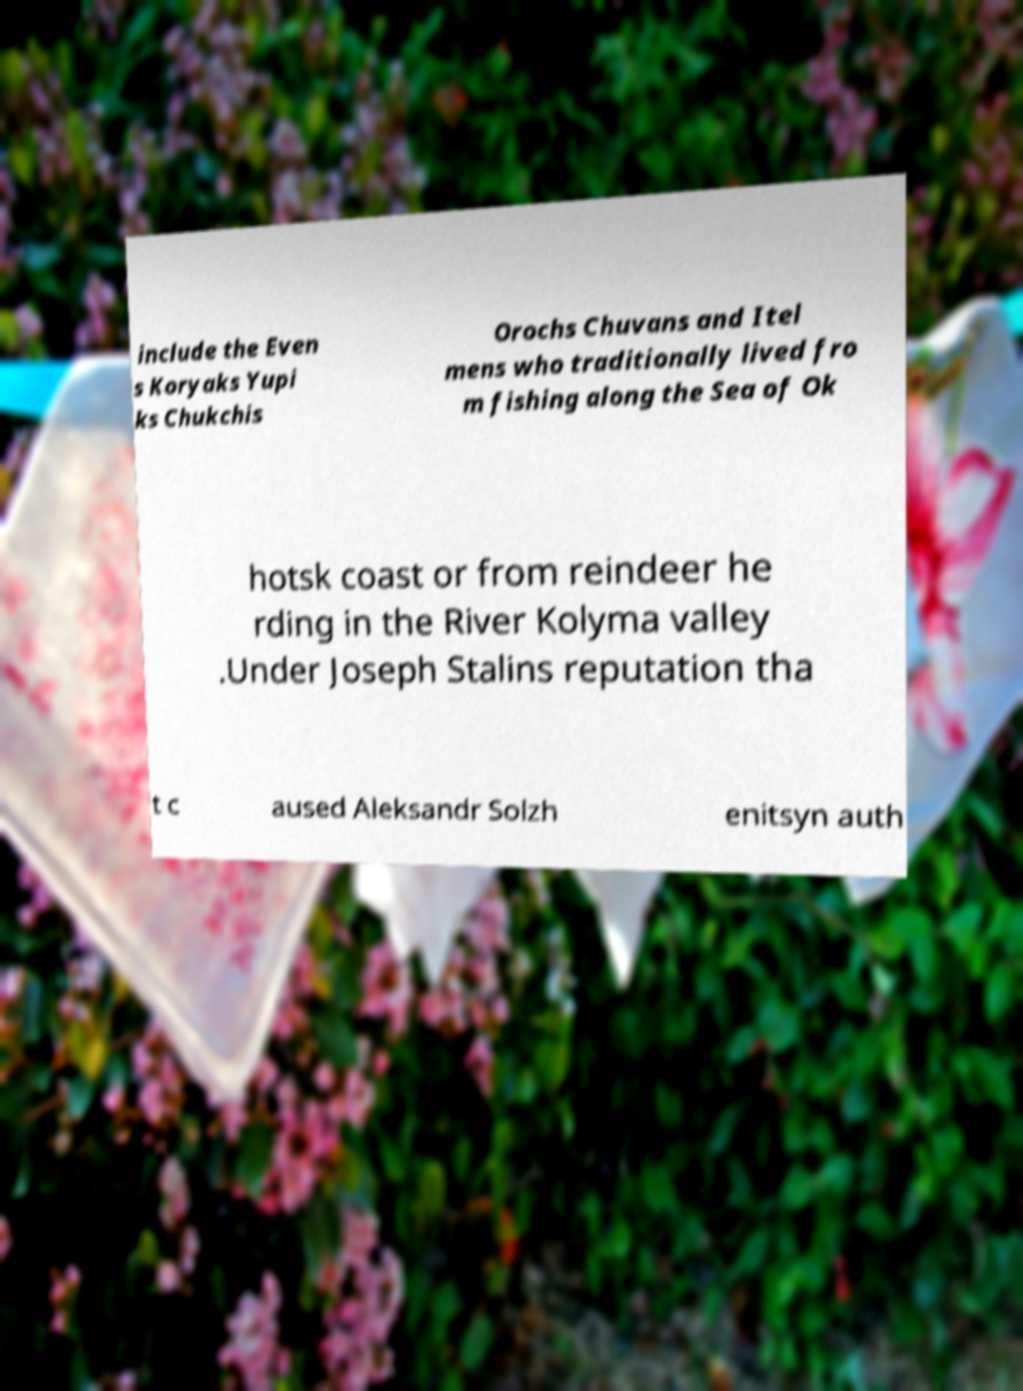For documentation purposes, I need the text within this image transcribed. Could you provide that? include the Even s Koryaks Yupi ks Chukchis Orochs Chuvans and Itel mens who traditionally lived fro m fishing along the Sea of Ok hotsk coast or from reindeer he rding in the River Kolyma valley .Under Joseph Stalins reputation tha t c aused Aleksandr Solzh enitsyn auth 